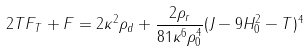<formula> <loc_0><loc_0><loc_500><loc_500>2 T F _ { T } + F = 2 \kappa ^ { 2 } \rho _ { d } + \frac { 2 \rho _ { r } } { 8 1 \kappa ^ { 6 } \rho _ { 0 } ^ { 4 } } ( J - 9 H _ { 0 } ^ { 2 } - T ) ^ { 4 }</formula> 